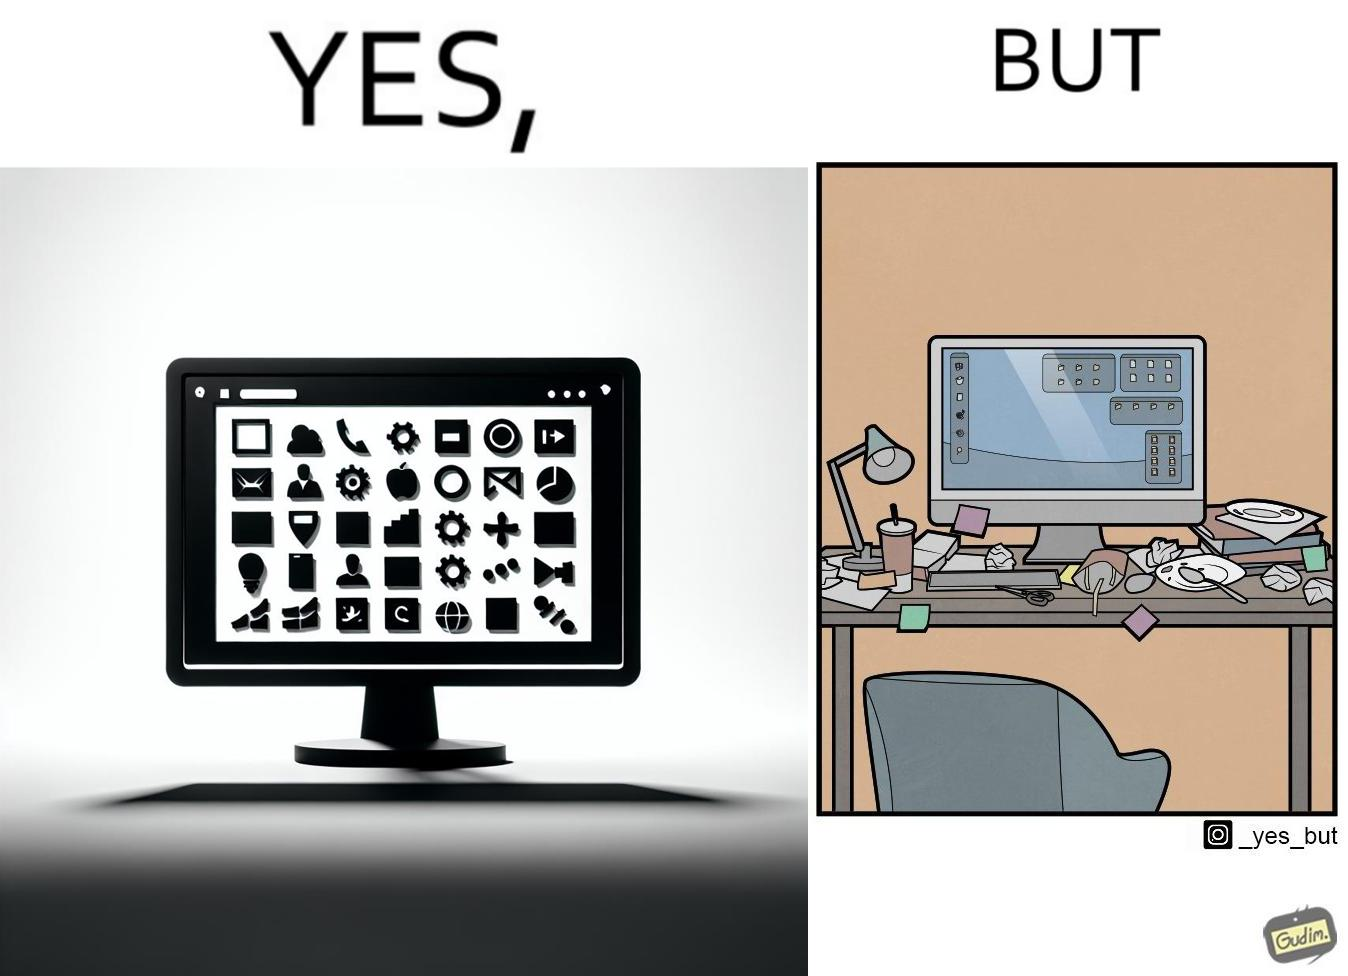What do you see in each half of this image? In the left part of the image: A desktop screen opened in a computer monitor. In the right part of the image: A desktop screen opened in a computer monitor on a table littered with used food packets, dirty plates, and wrappers 